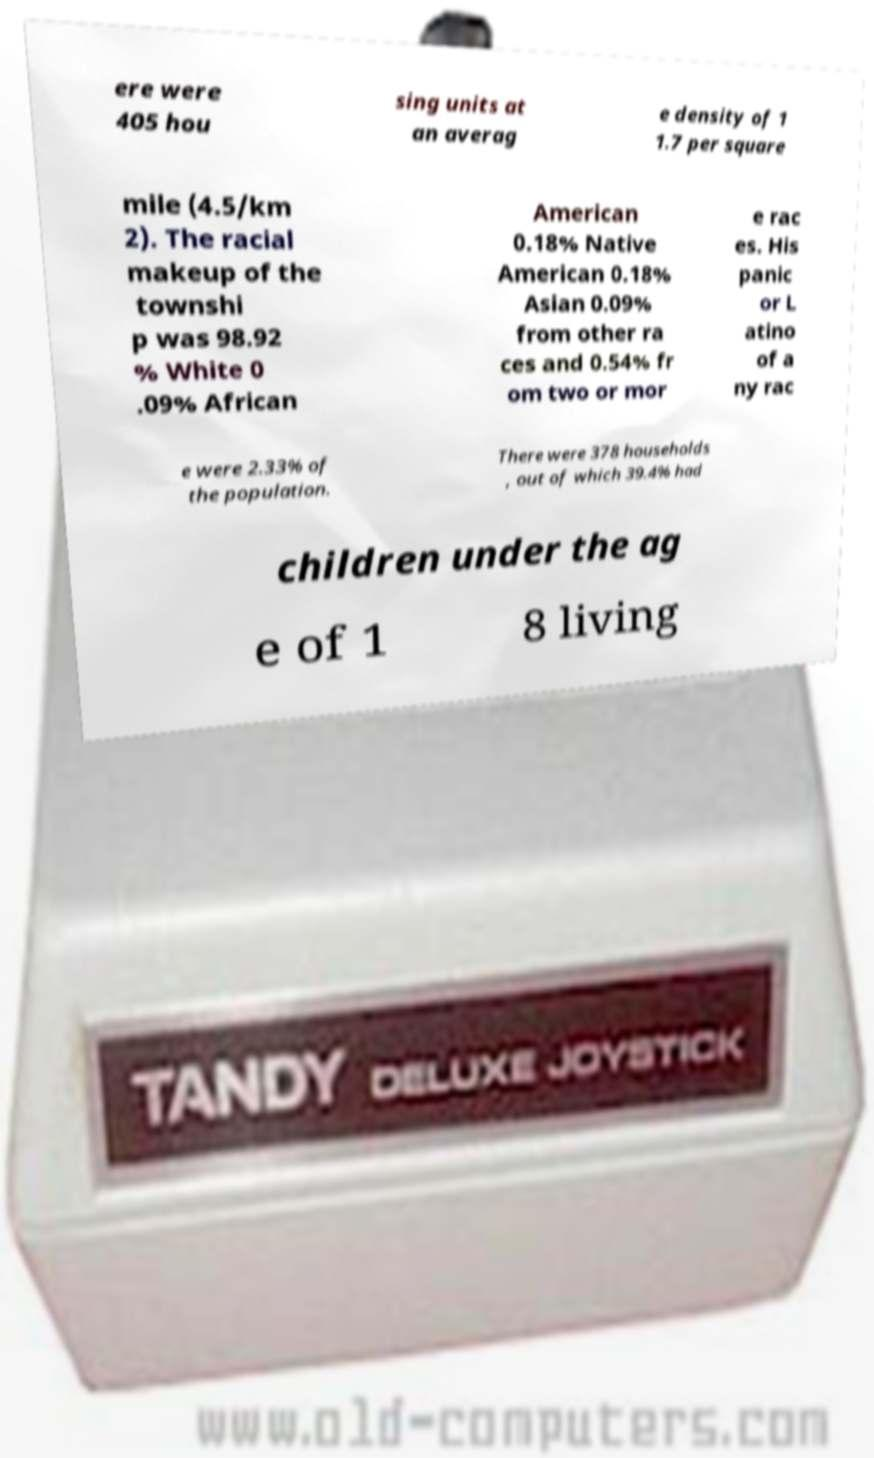Please identify and transcribe the text found in this image. ere were 405 hou sing units at an averag e density of 1 1.7 per square mile (4.5/km 2). The racial makeup of the townshi p was 98.92 % White 0 .09% African American 0.18% Native American 0.18% Asian 0.09% from other ra ces and 0.54% fr om two or mor e rac es. His panic or L atino of a ny rac e were 2.33% of the population. There were 378 households , out of which 39.4% had children under the ag e of 1 8 living 